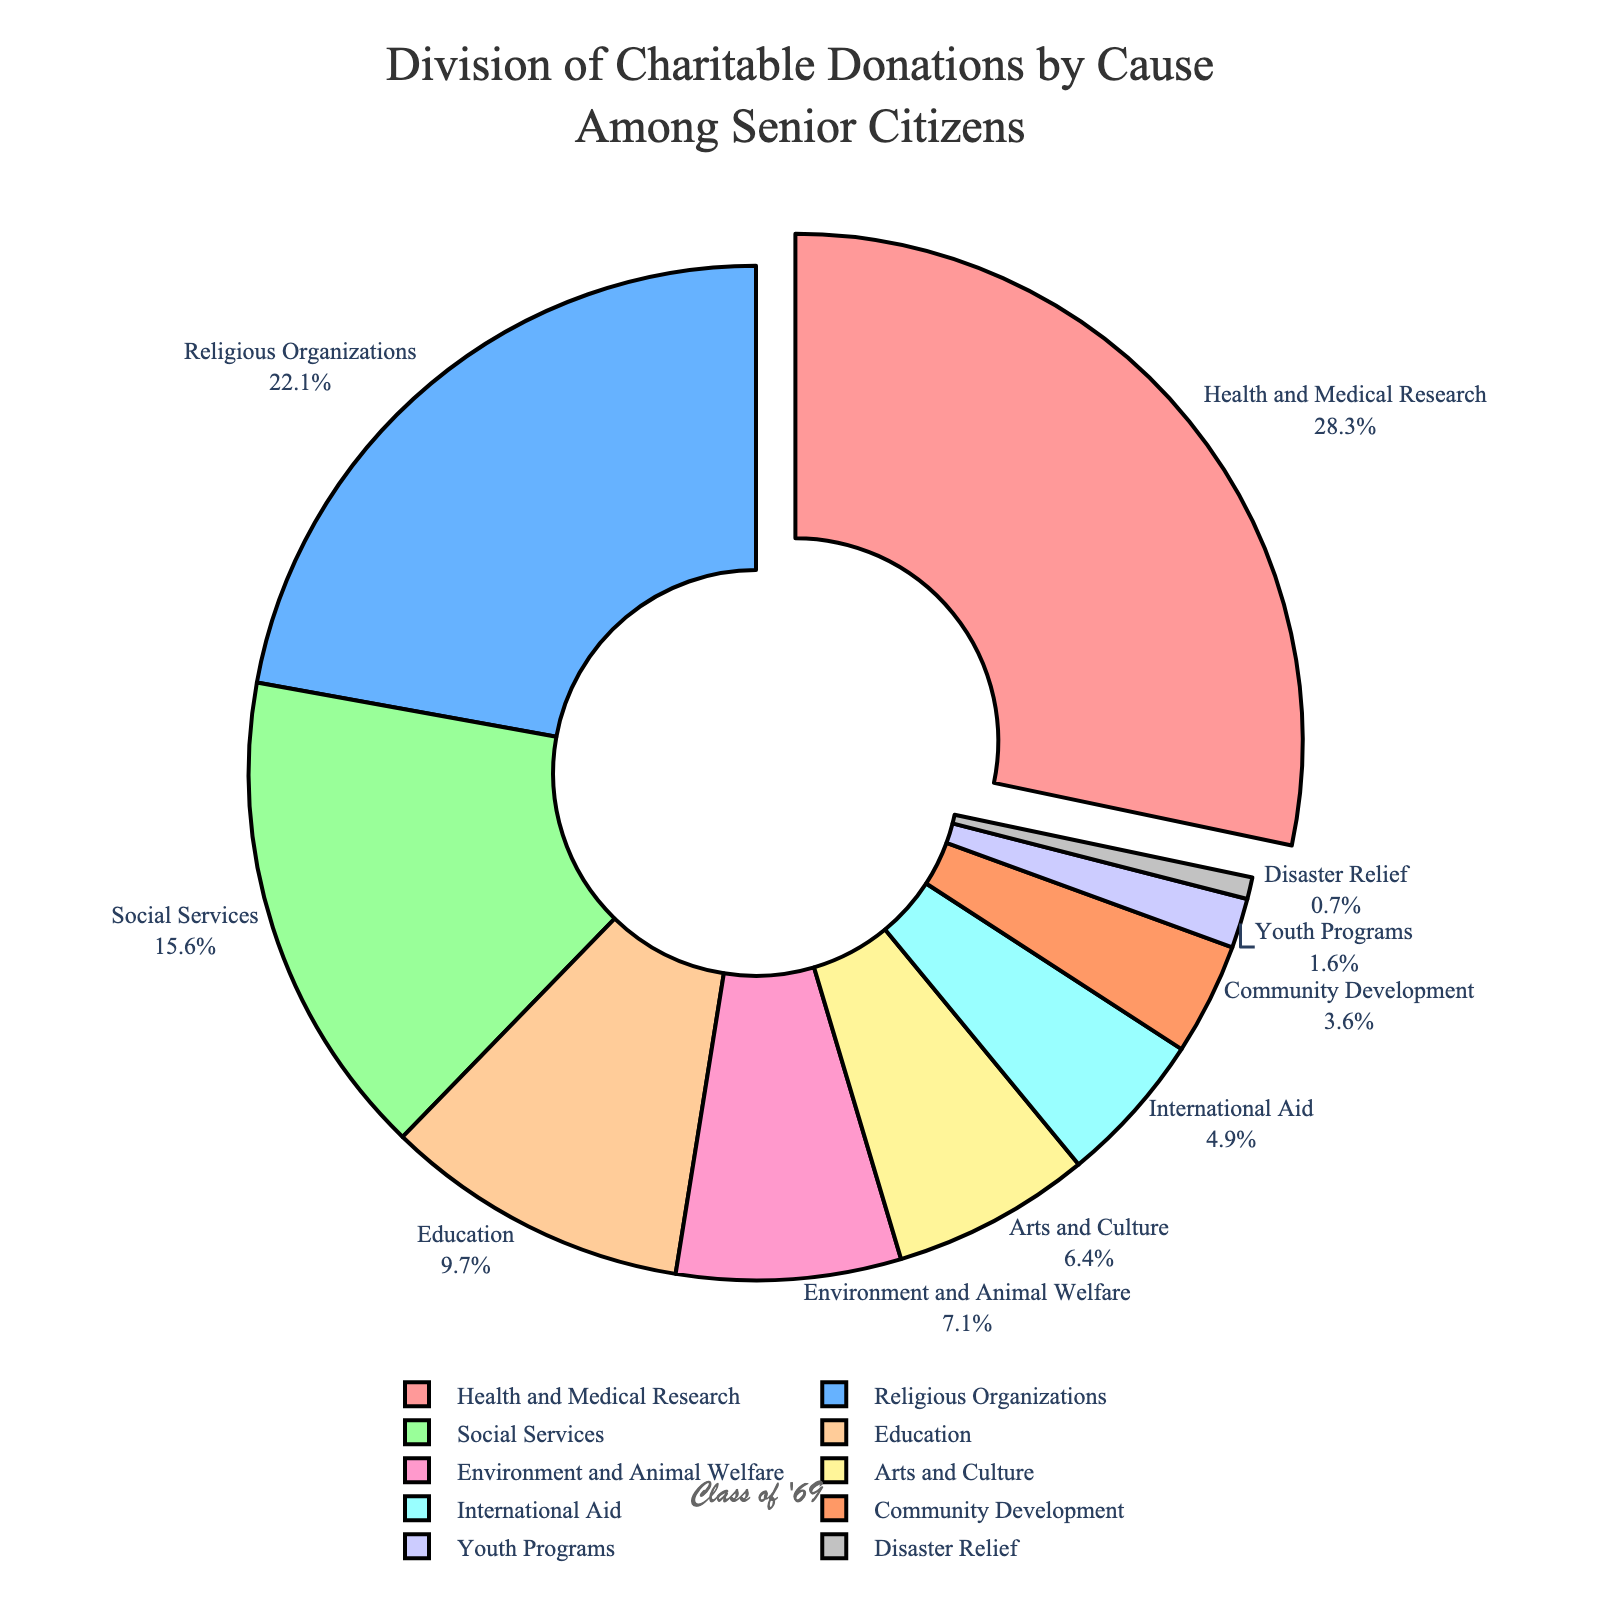Which cause received the highest percentage of donations? The highest percentage can be found by looking at the chart and identifying the cause with the largest slice. The largest slice is "Health and Medical Research" with 28.5% of donations.
Answer: Health and Medical Research How much more in percentage does Health and Medical Research receive compared to Community Development? First, locate the percentages for "Health and Medical Research" (28.5%) and "Community Development" (3.6%). The difference is calculated as 28.5% - 3.6%.
Answer: 24.9% Which two causes together receive less than 5% of total donations? Locate all the causes and their percentages, then find pairs that sum up to less than 5%. "Disaster Relief" has 0.7% and "Youth Programs" has 1.6%. Their sum is 0.7% + 1.6% = 2.3% which is less than 5%.
Answer: Disaster Relief and Youth Programs Compare the donations to Social Services and Education. Which one received a higher percentage and by how much? Identify the percentages for "Social Services" (15.7%) and "Education" (9.8%). Calculate the difference: 15.7% - 9.8%.
Answer: Social Services by 5.9% What color represents the Environment and Animal Welfare segment? Identify the label "Environment and Animal Welfare" in the pie chart and note the color of its segment. The color for this segment is green.
Answer: Green What is the combined percentage of donations towards Religious Organizations and Arts and Culture? Add the percentages for "Religious Organizations" (22.3%) and "Arts and Culture" (6.4%). The total is 22.3% + 6.4%.
Answer: 28.7% Among the categories with less than 10% in donations, which one receives the highest percentage? List the categories with less than 10% and identify the one with the highest value: "Education" (9.8%), "Environment and Animal Welfare" (7.2%), "Arts and Culture" (6.4%), "International Aid" (4.9%), "Community Development" (3.6%), "Youth Programs" (1.6%), "Disaster Relief" (0.7%). Education has the highest percentage.
Answer: Education What is the percentage difference between donations to International Aid and Youth Programs? Find the percentages for "International Aid" (4.9%) and "Youth Programs" (1.6%), then calculate the difference: 4.9% - 1.6%.
Answer: 3.3% Which cause receives nearly one-fourth of the total donations? One-fourth of 100% is 25%. Identify the segment closest to 25%. "Religious Organizations" with 22.3% is closest to one-fourth of the total donations.
Answer: Religious Organizations 